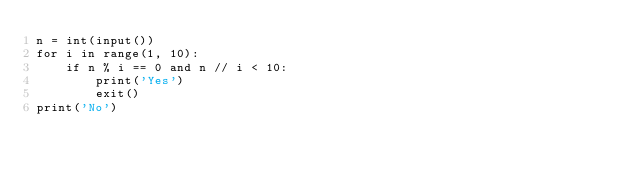<code> <loc_0><loc_0><loc_500><loc_500><_Python_>n = int(input())
for i in range(1, 10):
    if n % i == 0 and n // i < 10:
        print('Yes')
        exit()
print('No')</code> 